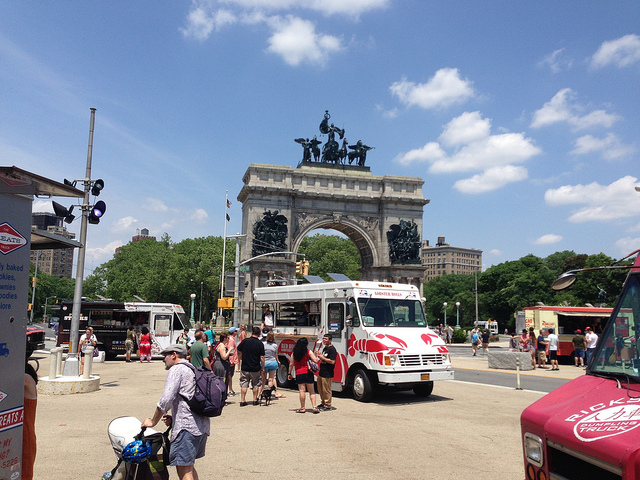Imagine that this scene is part of a movie set. What kind of movie would it be and how would this setting contribute to the story? This scene could be a part of a dynamic urban adventure or a romantic comedy. The grand monument provides a majestic backdrop that sets the tone for significant events or meetings in the story. If it’s an adventure film, the characters might use the busy, scenic landmark as a meeting point before embarking on a thrilling quest through the city. In a romantic comedy, this setting could be where the protagonists coincidentally meet or reunite, with the lively atmosphere capturing the serendipity and excitement of their encounters. If you were to write a historical fiction novel centered around this monument, what would be the central plot? In a historical fiction novel centered around this monument, the central plot could revolve around the monument's construction during a pivotal time in the region's history. The story could follow the life of an architect tasked with designing the monument, exploring the political struggles and personal sacrifices involved. Intertwined with this narrative could be the experiences of a young couple whose lives are deeply impacted by the events the monument commemorates, linking personal stories with broader historical themes. 